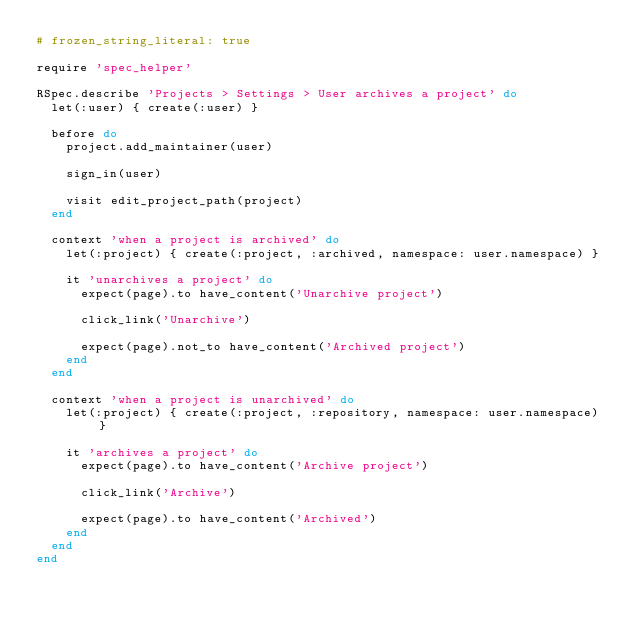Convert code to text. <code><loc_0><loc_0><loc_500><loc_500><_Ruby_># frozen_string_literal: true

require 'spec_helper'

RSpec.describe 'Projects > Settings > User archives a project' do
  let(:user) { create(:user) }

  before do
    project.add_maintainer(user)

    sign_in(user)

    visit edit_project_path(project)
  end

  context 'when a project is archived' do
    let(:project) { create(:project, :archived, namespace: user.namespace) }

    it 'unarchives a project' do
      expect(page).to have_content('Unarchive project')

      click_link('Unarchive')

      expect(page).not_to have_content('Archived project')
    end
  end

  context 'when a project is unarchived' do
    let(:project) { create(:project, :repository, namespace: user.namespace) }

    it 'archives a project' do
      expect(page).to have_content('Archive project')

      click_link('Archive')

      expect(page).to have_content('Archived')
    end
  end
end
</code> 